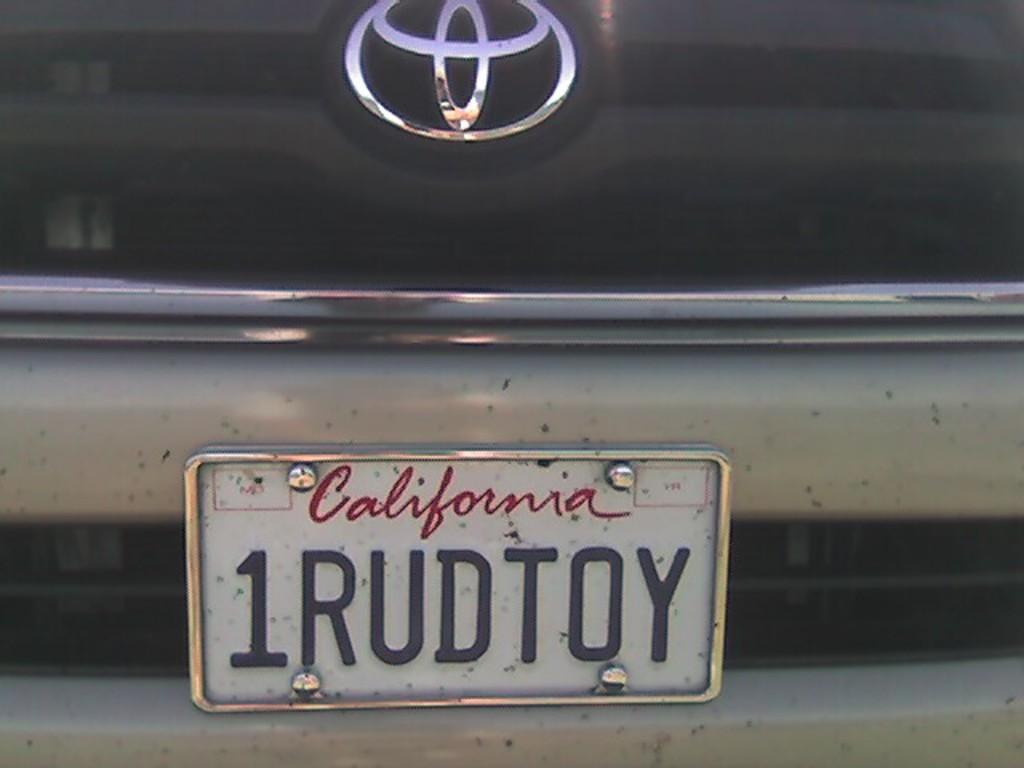Provide a one-sentence caption for the provided image. A license plate from California is on a Toyota and read 1RUDTOY. 